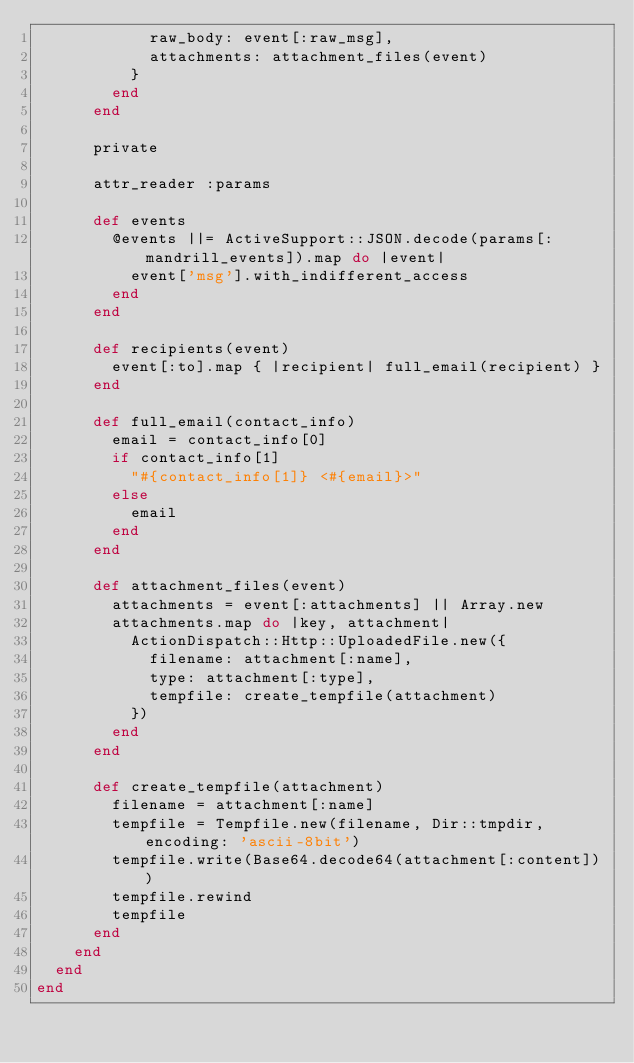Convert code to text. <code><loc_0><loc_0><loc_500><loc_500><_Ruby_>            raw_body: event[:raw_msg],
            attachments: attachment_files(event)
          }
        end
      end

      private

      attr_reader :params

      def events
        @events ||= ActiveSupport::JSON.decode(params[:mandrill_events]).map do |event|
          event['msg'].with_indifferent_access
        end
      end

      def recipients(event)
        event[:to].map { |recipient| full_email(recipient) }
      end

      def full_email(contact_info)
        email = contact_info[0]
        if contact_info[1]
          "#{contact_info[1]} <#{email}>"
        else
          email
        end
      end

      def attachment_files(event)
        attachments = event[:attachments] || Array.new
        attachments.map do |key, attachment|
          ActionDispatch::Http::UploadedFile.new({
            filename: attachment[:name],
            type: attachment[:type],
            tempfile: create_tempfile(attachment)
          })
        end
      end

      def create_tempfile(attachment)
        filename = attachment[:name]
        tempfile = Tempfile.new(filename, Dir::tmpdir, encoding: 'ascii-8bit')
        tempfile.write(Base64.decode64(attachment[:content]))
        tempfile.rewind
        tempfile
      end
    end
  end
end
</code> 